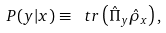Convert formula to latex. <formula><loc_0><loc_0><loc_500><loc_500>P ( y | x ) \equiv \ t r \left ( \hat { \Pi } _ { y } \hat { \rho } _ { x } \right ) ,</formula> 